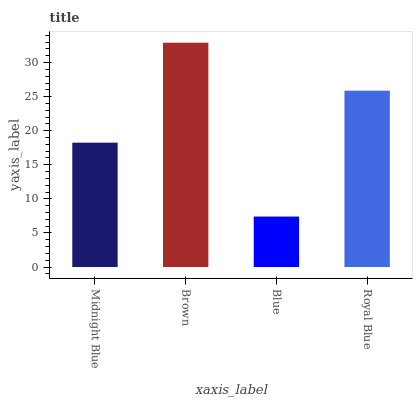Is Blue the minimum?
Answer yes or no. Yes. Is Brown the maximum?
Answer yes or no. Yes. Is Brown the minimum?
Answer yes or no. No. Is Blue the maximum?
Answer yes or no. No. Is Brown greater than Blue?
Answer yes or no. Yes. Is Blue less than Brown?
Answer yes or no. Yes. Is Blue greater than Brown?
Answer yes or no. No. Is Brown less than Blue?
Answer yes or no. No. Is Royal Blue the high median?
Answer yes or no. Yes. Is Midnight Blue the low median?
Answer yes or no. Yes. Is Brown the high median?
Answer yes or no. No. Is Royal Blue the low median?
Answer yes or no. No. 